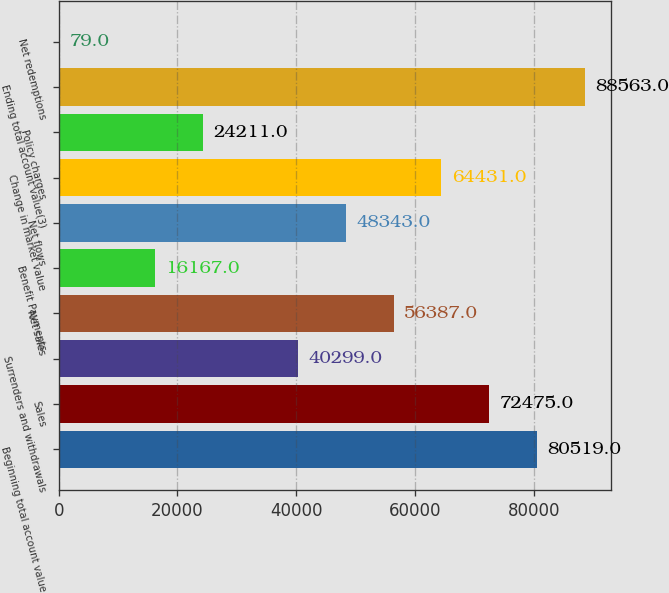<chart> <loc_0><loc_0><loc_500><loc_500><bar_chart><fcel>Beginning total account value<fcel>Sales<fcel>Surrenders and withdrawals<fcel>Net sales<fcel>Benefit Payments<fcel>Net flows<fcel>Change in market value<fcel>Policy charges<fcel>Ending total account value(3)<fcel>Net redemptions<nl><fcel>80519<fcel>72475<fcel>40299<fcel>56387<fcel>16167<fcel>48343<fcel>64431<fcel>24211<fcel>88563<fcel>79<nl></chart> 